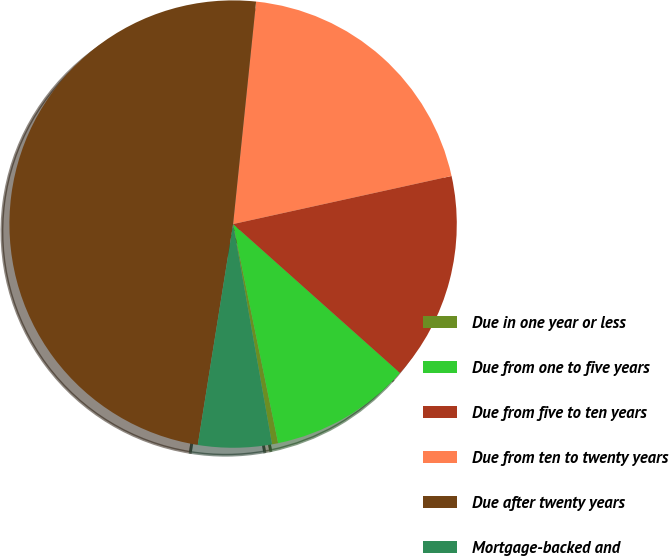<chart> <loc_0><loc_0><loc_500><loc_500><pie_chart><fcel>Due in one year or less<fcel>Due from one to five years<fcel>Due from five to ten years<fcel>Due from ten to twenty years<fcel>Due after twenty years<fcel>Mortgage-backed and<nl><fcel>0.44%<fcel>10.18%<fcel>15.04%<fcel>19.91%<fcel>49.11%<fcel>5.31%<nl></chart> 